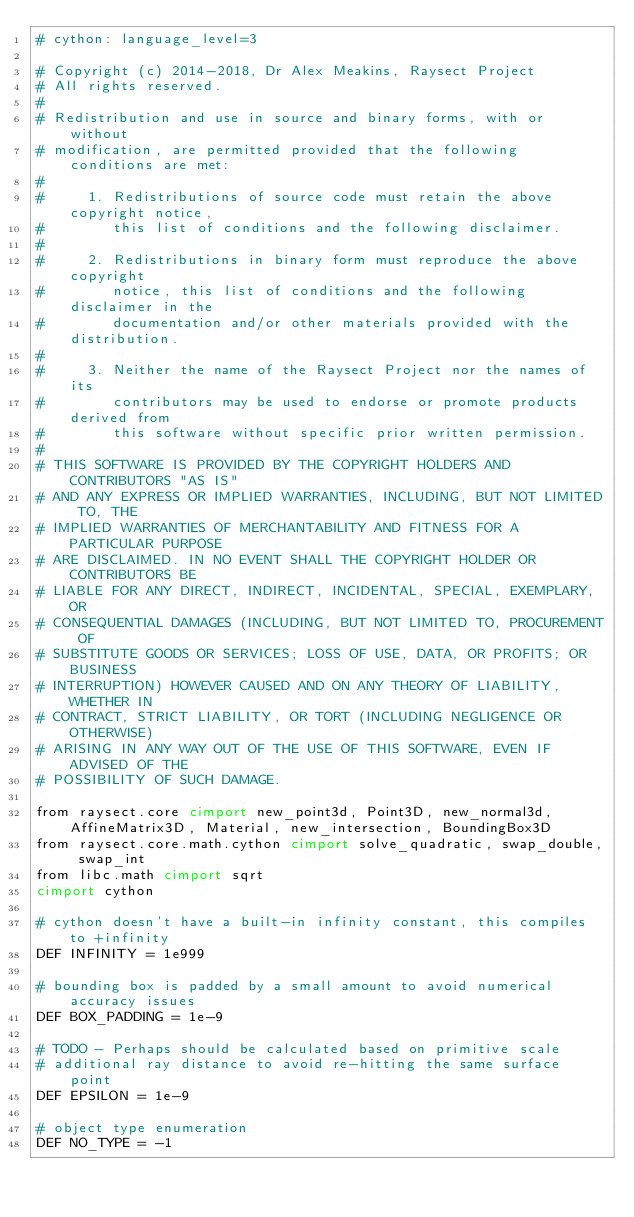Convert code to text. <code><loc_0><loc_0><loc_500><loc_500><_Cython_># cython: language_level=3

# Copyright (c) 2014-2018, Dr Alex Meakins, Raysect Project
# All rights reserved.
#
# Redistribution and use in source and binary forms, with or without
# modification, are permitted provided that the following conditions are met:
#
#     1. Redistributions of source code must retain the above copyright notice,
#        this list of conditions and the following disclaimer.
#
#     2. Redistributions in binary form must reproduce the above copyright
#        notice, this list of conditions and the following disclaimer in the
#        documentation and/or other materials provided with the distribution.
#
#     3. Neither the name of the Raysect Project nor the names of its
#        contributors may be used to endorse or promote products derived from
#        this software without specific prior written permission.
#
# THIS SOFTWARE IS PROVIDED BY THE COPYRIGHT HOLDERS AND CONTRIBUTORS "AS IS"
# AND ANY EXPRESS OR IMPLIED WARRANTIES, INCLUDING, BUT NOT LIMITED TO, THE
# IMPLIED WARRANTIES OF MERCHANTABILITY AND FITNESS FOR A PARTICULAR PURPOSE
# ARE DISCLAIMED. IN NO EVENT SHALL THE COPYRIGHT HOLDER OR CONTRIBUTORS BE
# LIABLE FOR ANY DIRECT, INDIRECT, INCIDENTAL, SPECIAL, EXEMPLARY, OR
# CONSEQUENTIAL DAMAGES (INCLUDING, BUT NOT LIMITED TO, PROCUREMENT OF
# SUBSTITUTE GOODS OR SERVICES; LOSS OF USE, DATA, OR PROFITS; OR BUSINESS
# INTERRUPTION) HOWEVER CAUSED AND ON ANY THEORY OF LIABILITY, WHETHER IN
# CONTRACT, STRICT LIABILITY, OR TORT (INCLUDING NEGLIGENCE OR OTHERWISE)
# ARISING IN ANY WAY OUT OF THE USE OF THIS SOFTWARE, EVEN IF ADVISED OF THE
# POSSIBILITY OF SUCH DAMAGE.

from raysect.core cimport new_point3d, Point3D, new_normal3d, AffineMatrix3D, Material, new_intersection, BoundingBox3D
from raysect.core.math.cython cimport solve_quadratic, swap_double, swap_int
from libc.math cimport sqrt
cimport cython

# cython doesn't have a built-in infinity constant, this compiles to +infinity
DEF INFINITY = 1e999

# bounding box is padded by a small amount to avoid numerical accuracy issues
DEF BOX_PADDING = 1e-9

# TODO - Perhaps should be calculated based on primitive scale
# additional ray distance to avoid re-hitting the same surface point
DEF EPSILON = 1e-9

# object type enumeration
DEF NO_TYPE = -1</code> 